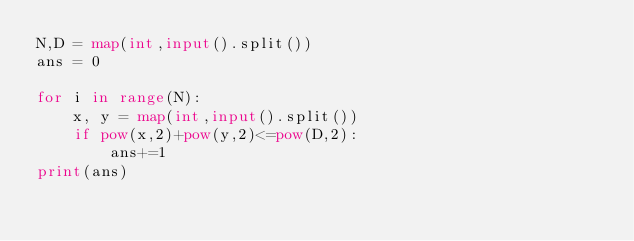Convert code to text. <code><loc_0><loc_0><loc_500><loc_500><_Python_>N,D = map(int,input().split())
ans = 0

for i in range(N):
    x, y = map(int,input().split())
    if pow(x,2)+pow(y,2)<=pow(D,2):
        ans+=1
print(ans)
</code> 